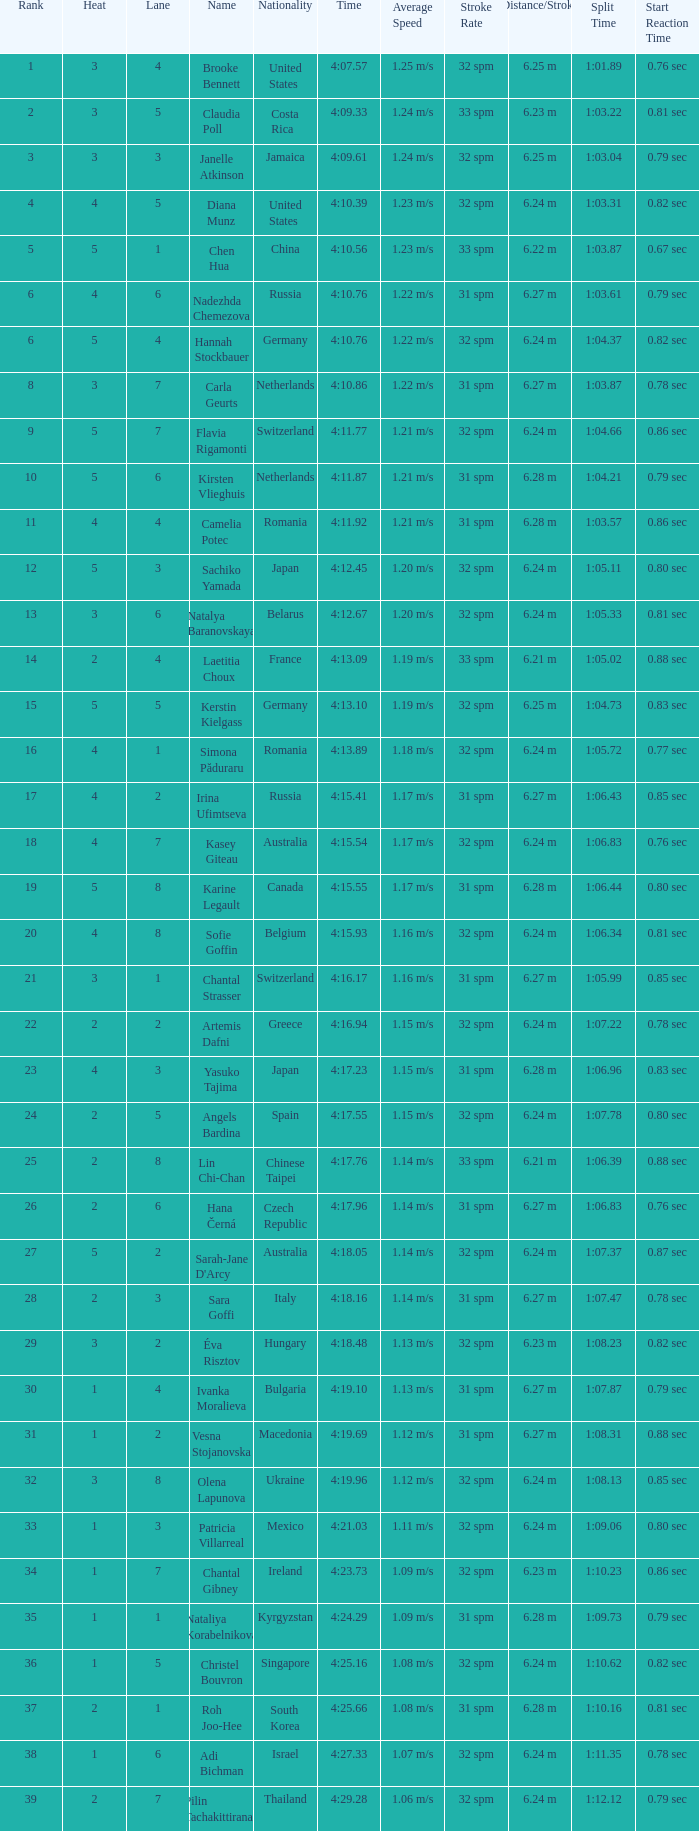Name the average rank with larger than 3 and heat more than 5 None. 